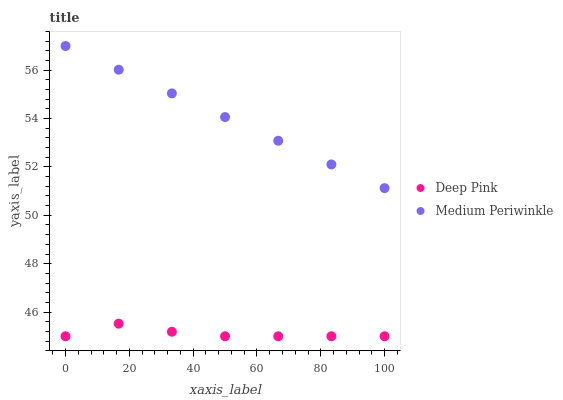Does Deep Pink have the minimum area under the curve?
Answer yes or no. Yes. Does Medium Periwinkle have the maximum area under the curve?
Answer yes or no. Yes. Does Medium Periwinkle have the minimum area under the curve?
Answer yes or no. No. Is Medium Periwinkle the smoothest?
Answer yes or no. Yes. Is Deep Pink the roughest?
Answer yes or no. Yes. Is Medium Periwinkle the roughest?
Answer yes or no. No. Does Deep Pink have the lowest value?
Answer yes or no. Yes. Does Medium Periwinkle have the lowest value?
Answer yes or no. No. Does Medium Periwinkle have the highest value?
Answer yes or no. Yes. Is Deep Pink less than Medium Periwinkle?
Answer yes or no. Yes. Is Medium Periwinkle greater than Deep Pink?
Answer yes or no. Yes. Does Deep Pink intersect Medium Periwinkle?
Answer yes or no. No. 